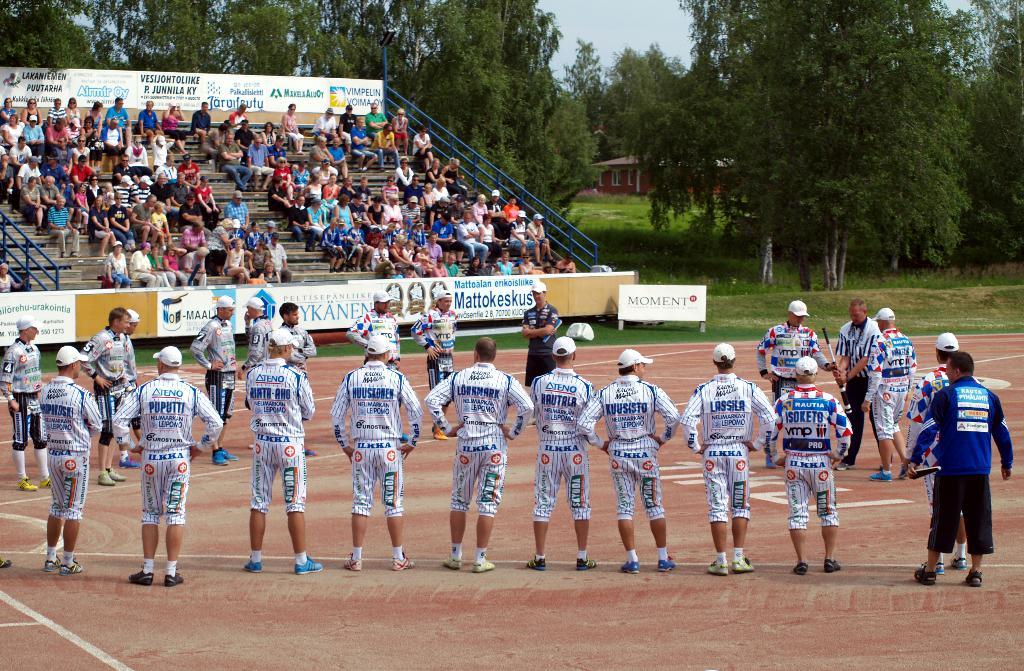What is a sponsor name?
Make the answer very short. Moment. What is the word on the white sign in the middle?
Keep it short and to the point. Moment. 